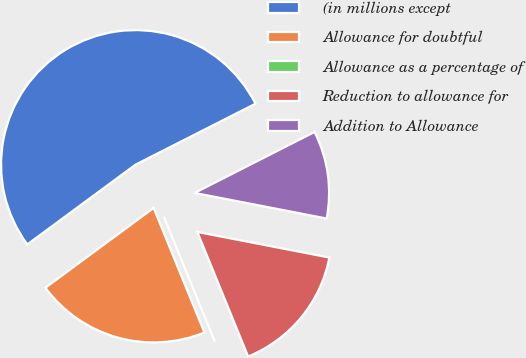Convert chart to OTSL. <chart><loc_0><loc_0><loc_500><loc_500><pie_chart><fcel>(in millions except<fcel>Allowance for doubtful<fcel>Allowance as a percentage of<fcel>Reduction to allowance for<fcel>Addition to Allowance<nl><fcel>52.63%<fcel>21.05%<fcel>0.0%<fcel>15.79%<fcel>10.53%<nl></chart> 